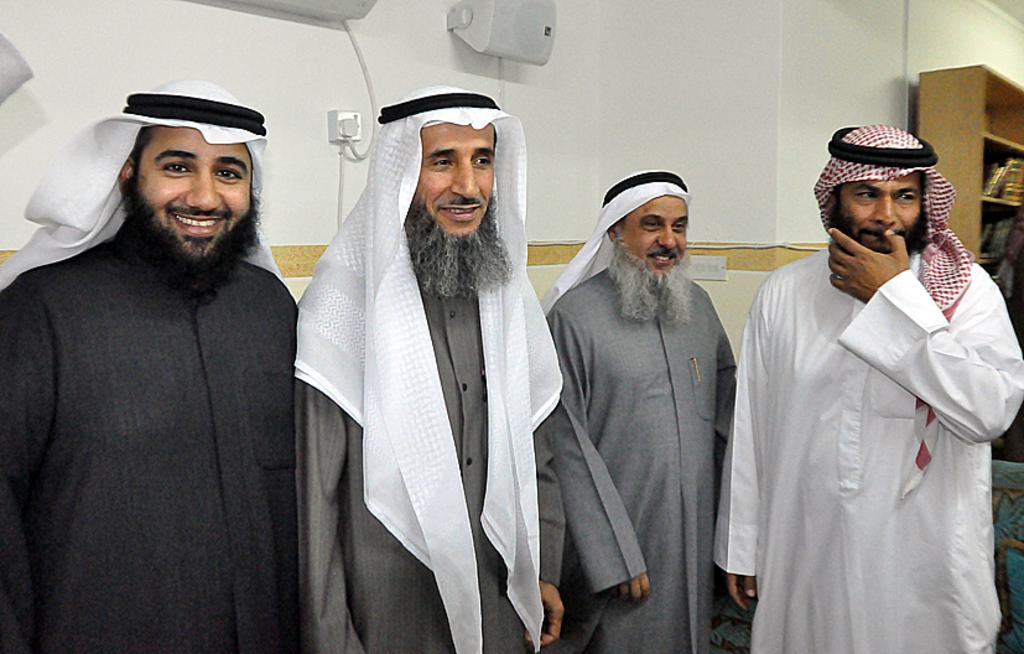How many people are in the image? There is a group of persons in the image. What are the persons doing in the image? The persons are standing on the floor. What can be seen on the heads of the persons in the image? The persons are wearing turbans. What objects can be seen in the background of the image? There is an air conditioner, a speaker, and shelves in the background of the image. What is the background of the image made of? There is a wall in the background of the image. What type of bomb is visible in the image? There is no bomb present in the image. What is the reason for the persons wearing turbans in the image? The image does not provide any information about the reason for the persons wearing turbans. 